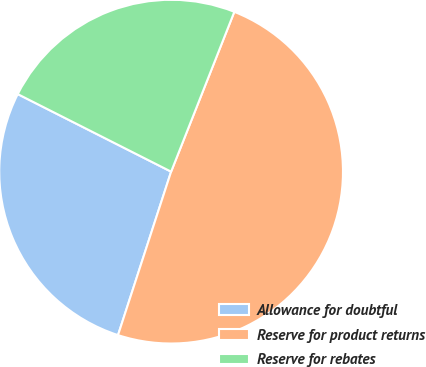Convert chart to OTSL. <chart><loc_0><loc_0><loc_500><loc_500><pie_chart><fcel>Allowance for doubtful<fcel>Reserve for product returns<fcel>Reserve for rebates<nl><fcel>27.45%<fcel>49.0%<fcel>23.54%<nl></chart> 